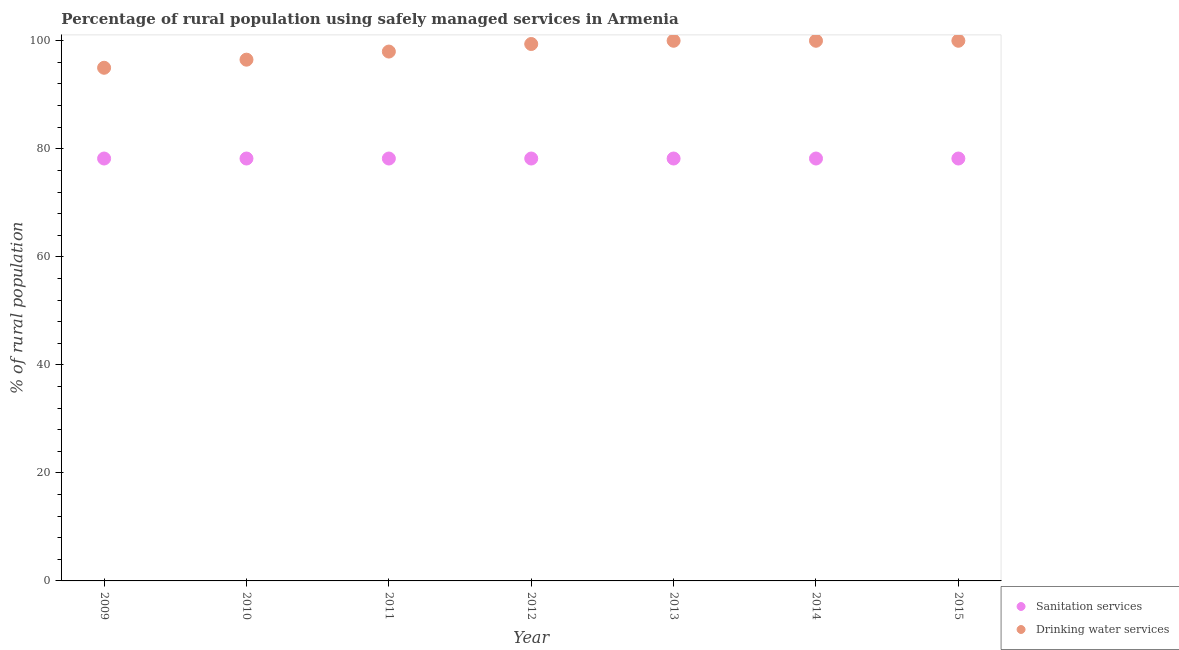Is the number of dotlines equal to the number of legend labels?
Your response must be concise. Yes. What is the percentage of rural population who used sanitation services in 2009?
Your response must be concise. 78.2. Across all years, what is the maximum percentage of rural population who used sanitation services?
Your answer should be compact. 78.2. Across all years, what is the minimum percentage of rural population who used sanitation services?
Your answer should be compact. 78.2. In which year was the percentage of rural population who used sanitation services maximum?
Provide a short and direct response. 2009. In which year was the percentage of rural population who used drinking water services minimum?
Offer a terse response. 2009. What is the total percentage of rural population who used drinking water services in the graph?
Ensure brevity in your answer.  688.9. What is the difference between the percentage of rural population who used drinking water services in 2011 and that in 2014?
Give a very brief answer. -2. What is the difference between the percentage of rural population who used sanitation services in 2013 and the percentage of rural population who used drinking water services in 2009?
Offer a terse response. -16.8. What is the average percentage of rural population who used drinking water services per year?
Make the answer very short. 98.41. In the year 2009, what is the difference between the percentage of rural population who used sanitation services and percentage of rural population who used drinking water services?
Offer a terse response. -16.8. What is the ratio of the percentage of rural population who used drinking water services in 2012 to that in 2013?
Your response must be concise. 0.99. What is the difference between the highest and the second highest percentage of rural population who used drinking water services?
Your response must be concise. 0. Is the sum of the percentage of rural population who used sanitation services in 2010 and 2013 greater than the maximum percentage of rural population who used drinking water services across all years?
Give a very brief answer. Yes. Is the percentage of rural population who used sanitation services strictly greater than the percentage of rural population who used drinking water services over the years?
Make the answer very short. No. Is the percentage of rural population who used sanitation services strictly less than the percentage of rural population who used drinking water services over the years?
Offer a very short reply. Yes. How many dotlines are there?
Your response must be concise. 2. How many years are there in the graph?
Your answer should be very brief. 7. What is the difference between two consecutive major ticks on the Y-axis?
Offer a terse response. 20. Where does the legend appear in the graph?
Your answer should be very brief. Bottom right. What is the title of the graph?
Keep it short and to the point. Percentage of rural population using safely managed services in Armenia. What is the label or title of the Y-axis?
Your answer should be compact. % of rural population. What is the % of rural population in Sanitation services in 2009?
Offer a terse response. 78.2. What is the % of rural population of Drinking water services in 2009?
Keep it short and to the point. 95. What is the % of rural population in Sanitation services in 2010?
Offer a terse response. 78.2. What is the % of rural population in Drinking water services in 2010?
Make the answer very short. 96.5. What is the % of rural population of Sanitation services in 2011?
Your response must be concise. 78.2. What is the % of rural population in Drinking water services in 2011?
Offer a very short reply. 98. What is the % of rural population of Sanitation services in 2012?
Keep it short and to the point. 78.2. What is the % of rural population in Drinking water services in 2012?
Ensure brevity in your answer.  99.4. What is the % of rural population of Sanitation services in 2013?
Give a very brief answer. 78.2. What is the % of rural population of Sanitation services in 2014?
Keep it short and to the point. 78.2. What is the % of rural population of Drinking water services in 2014?
Your answer should be compact. 100. What is the % of rural population in Sanitation services in 2015?
Your answer should be very brief. 78.2. Across all years, what is the maximum % of rural population of Sanitation services?
Your response must be concise. 78.2. Across all years, what is the minimum % of rural population in Sanitation services?
Offer a very short reply. 78.2. What is the total % of rural population in Sanitation services in the graph?
Offer a very short reply. 547.4. What is the total % of rural population of Drinking water services in the graph?
Keep it short and to the point. 688.9. What is the difference between the % of rural population in Sanitation services in 2009 and that in 2010?
Offer a very short reply. 0. What is the difference between the % of rural population in Drinking water services in 2009 and that in 2010?
Keep it short and to the point. -1.5. What is the difference between the % of rural population in Sanitation services in 2009 and that in 2012?
Provide a succinct answer. 0. What is the difference between the % of rural population in Drinking water services in 2009 and that in 2012?
Keep it short and to the point. -4.4. What is the difference between the % of rural population of Drinking water services in 2009 and that in 2014?
Offer a very short reply. -5. What is the difference between the % of rural population in Sanitation services in 2009 and that in 2015?
Offer a terse response. 0. What is the difference between the % of rural population of Drinking water services in 2009 and that in 2015?
Offer a very short reply. -5. What is the difference between the % of rural population of Sanitation services in 2010 and that in 2011?
Your response must be concise. 0. What is the difference between the % of rural population in Sanitation services in 2010 and that in 2012?
Provide a succinct answer. 0. What is the difference between the % of rural population of Sanitation services in 2010 and that in 2013?
Keep it short and to the point. 0. What is the difference between the % of rural population of Drinking water services in 2010 and that in 2013?
Keep it short and to the point. -3.5. What is the difference between the % of rural population in Drinking water services in 2010 and that in 2015?
Give a very brief answer. -3.5. What is the difference between the % of rural population in Sanitation services in 2011 and that in 2012?
Your answer should be compact. 0. What is the difference between the % of rural population of Sanitation services in 2011 and that in 2014?
Offer a terse response. 0. What is the difference between the % of rural population of Drinking water services in 2011 and that in 2014?
Offer a terse response. -2. What is the difference between the % of rural population in Sanitation services in 2011 and that in 2015?
Ensure brevity in your answer.  0. What is the difference between the % of rural population in Drinking water services in 2011 and that in 2015?
Your answer should be very brief. -2. What is the difference between the % of rural population of Drinking water services in 2012 and that in 2013?
Provide a succinct answer. -0.6. What is the difference between the % of rural population of Sanitation services in 2013 and that in 2014?
Give a very brief answer. 0. What is the difference between the % of rural population in Drinking water services in 2013 and that in 2014?
Keep it short and to the point. 0. What is the difference between the % of rural population in Sanitation services in 2013 and that in 2015?
Offer a very short reply. 0. What is the difference between the % of rural population in Drinking water services in 2014 and that in 2015?
Provide a succinct answer. 0. What is the difference between the % of rural population of Sanitation services in 2009 and the % of rural population of Drinking water services in 2010?
Offer a terse response. -18.3. What is the difference between the % of rural population of Sanitation services in 2009 and the % of rural population of Drinking water services in 2011?
Offer a terse response. -19.8. What is the difference between the % of rural population of Sanitation services in 2009 and the % of rural population of Drinking water services in 2012?
Keep it short and to the point. -21.2. What is the difference between the % of rural population of Sanitation services in 2009 and the % of rural population of Drinking water services in 2013?
Your response must be concise. -21.8. What is the difference between the % of rural population of Sanitation services in 2009 and the % of rural population of Drinking water services in 2014?
Your response must be concise. -21.8. What is the difference between the % of rural population of Sanitation services in 2009 and the % of rural population of Drinking water services in 2015?
Ensure brevity in your answer.  -21.8. What is the difference between the % of rural population in Sanitation services in 2010 and the % of rural population in Drinking water services in 2011?
Keep it short and to the point. -19.8. What is the difference between the % of rural population of Sanitation services in 2010 and the % of rural population of Drinking water services in 2012?
Your response must be concise. -21.2. What is the difference between the % of rural population of Sanitation services in 2010 and the % of rural population of Drinking water services in 2013?
Provide a short and direct response. -21.8. What is the difference between the % of rural population in Sanitation services in 2010 and the % of rural population in Drinking water services in 2014?
Your response must be concise. -21.8. What is the difference between the % of rural population of Sanitation services in 2010 and the % of rural population of Drinking water services in 2015?
Provide a short and direct response. -21.8. What is the difference between the % of rural population of Sanitation services in 2011 and the % of rural population of Drinking water services in 2012?
Ensure brevity in your answer.  -21.2. What is the difference between the % of rural population in Sanitation services in 2011 and the % of rural population in Drinking water services in 2013?
Your answer should be compact. -21.8. What is the difference between the % of rural population of Sanitation services in 2011 and the % of rural population of Drinking water services in 2014?
Your answer should be very brief. -21.8. What is the difference between the % of rural population of Sanitation services in 2011 and the % of rural population of Drinking water services in 2015?
Make the answer very short. -21.8. What is the difference between the % of rural population in Sanitation services in 2012 and the % of rural population in Drinking water services in 2013?
Provide a short and direct response. -21.8. What is the difference between the % of rural population in Sanitation services in 2012 and the % of rural population in Drinking water services in 2014?
Provide a succinct answer. -21.8. What is the difference between the % of rural population of Sanitation services in 2012 and the % of rural population of Drinking water services in 2015?
Your answer should be compact. -21.8. What is the difference between the % of rural population of Sanitation services in 2013 and the % of rural population of Drinking water services in 2014?
Provide a succinct answer. -21.8. What is the difference between the % of rural population in Sanitation services in 2013 and the % of rural population in Drinking water services in 2015?
Your answer should be very brief. -21.8. What is the difference between the % of rural population of Sanitation services in 2014 and the % of rural population of Drinking water services in 2015?
Make the answer very short. -21.8. What is the average % of rural population in Sanitation services per year?
Ensure brevity in your answer.  78.2. What is the average % of rural population in Drinking water services per year?
Provide a succinct answer. 98.41. In the year 2009, what is the difference between the % of rural population of Sanitation services and % of rural population of Drinking water services?
Provide a succinct answer. -16.8. In the year 2010, what is the difference between the % of rural population of Sanitation services and % of rural population of Drinking water services?
Your response must be concise. -18.3. In the year 2011, what is the difference between the % of rural population of Sanitation services and % of rural population of Drinking water services?
Keep it short and to the point. -19.8. In the year 2012, what is the difference between the % of rural population in Sanitation services and % of rural population in Drinking water services?
Your response must be concise. -21.2. In the year 2013, what is the difference between the % of rural population in Sanitation services and % of rural population in Drinking water services?
Ensure brevity in your answer.  -21.8. In the year 2014, what is the difference between the % of rural population of Sanitation services and % of rural population of Drinking water services?
Offer a terse response. -21.8. In the year 2015, what is the difference between the % of rural population in Sanitation services and % of rural population in Drinking water services?
Make the answer very short. -21.8. What is the ratio of the % of rural population of Drinking water services in 2009 to that in 2010?
Your answer should be very brief. 0.98. What is the ratio of the % of rural population in Drinking water services in 2009 to that in 2011?
Your answer should be very brief. 0.97. What is the ratio of the % of rural population of Sanitation services in 2009 to that in 2012?
Your answer should be compact. 1. What is the ratio of the % of rural population of Drinking water services in 2009 to that in 2012?
Offer a very short reply. 0.96. What is the ratio of the % of rural population in Drinking water services in 2009 to that in 2013?
Offer a terse response. 0.95. What is the ratio of the % of rural population in Drinking water services in 2009 to that in 2014?
Give a very brief answer. 0.95. What is the ratio of the % of rural population of Sanitation services in 2009 to that in 2015?
Your answer should be very brief. 1. What is the ratio of the % of rural population in Drinking water services in 2009 to that in 2015?
Offer a very short reply. 0.95. What is the ratio of the % of rural population of Sanitation services in 2010 to that in 2011?
Offer a very short reply. 1. What is the ratio of the % of rural population of Drinking water services in 2010 to that in 2011?
Keep it short and to the point. 0.98. What is the ratio of the % of rural population in Drinking water services in 2010 to that in 2012?
Your answer should be very brief. 0.97. What is the ratio of the % of rural population in Sanitation services in 2010 to that in 2013?
Your response must be concise. 1. What is the ratio of the % of rural population in Sanitation services in 2010 to that in 2014?
Offer a very short reply. 1. What is the ratio of the % of rural population in Sanitation services in 2010 to that in 2015?
Offer a terse response. 1. What is the ratio of the % of rural population of Drinking water services in 2010 to that in 2015?
Provide a succinct answer. 0.96. What is the ratio of the % of rural population in Sanitation services in 2011 to that in 2012?
Your answer should be compact. 1. What is the ratio of the % of rural population of Drinking water services in 2011 to that in 2012?
Give a very brief answer. 0.99. What is the ratio of the % of rural population in Drinking water services in 2011 to that in 2013?
Your answer should be very brief. 0.98. What is the ratio of the % of rural population in Sanitation services in 2011 to that in 2014?
Offer a very short reply. 1. What is the ratio of the % of rural population in Sanitation services in 2011 to that in 2015?
Keep it short and to the point. 1. What is the ratio of the % of rural population in Drinking water services in 2012 to that in 2013?
Provide a succinct answer. 0.99. What is the ratio of the % of rural population in Sanitation services in 2012 to that in 2015?
Make the answer very short. 1. What is the ratio of the % of rural population of Sanitation services in 2013 to that in 2014?
Give a very brief answer. 1. What is the ratio of the % of rural population of Sanitation services in 2014 to that in 2015?
Your answer should be compact. 1. What is the ratio of the % of rural population of Drinking water services in 2014 to that in 2015?
Offer a very short reply. 1. What is the difference between the highest and the second highest % of rural population in Sanitation services?
Offer a very short reply. 0. What is the difference between the highest and the second highest % of rural population in Drinking water services?
Ensure brevity in your answer.  0. 